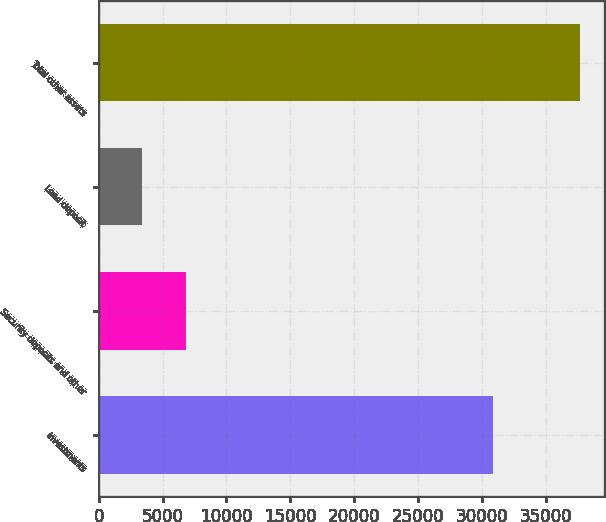Convert chart to OTSL. <chart><loc_0><loc_0><loc_500><loc_500><bar_chart><fcel>Investments<fcel>Security deposits and other<fcel>Land deposit<fcel>Total other assets<nl><fcel>30840<fcel>6812.3<fcel>3378<fcel>37721<nl></chart> 